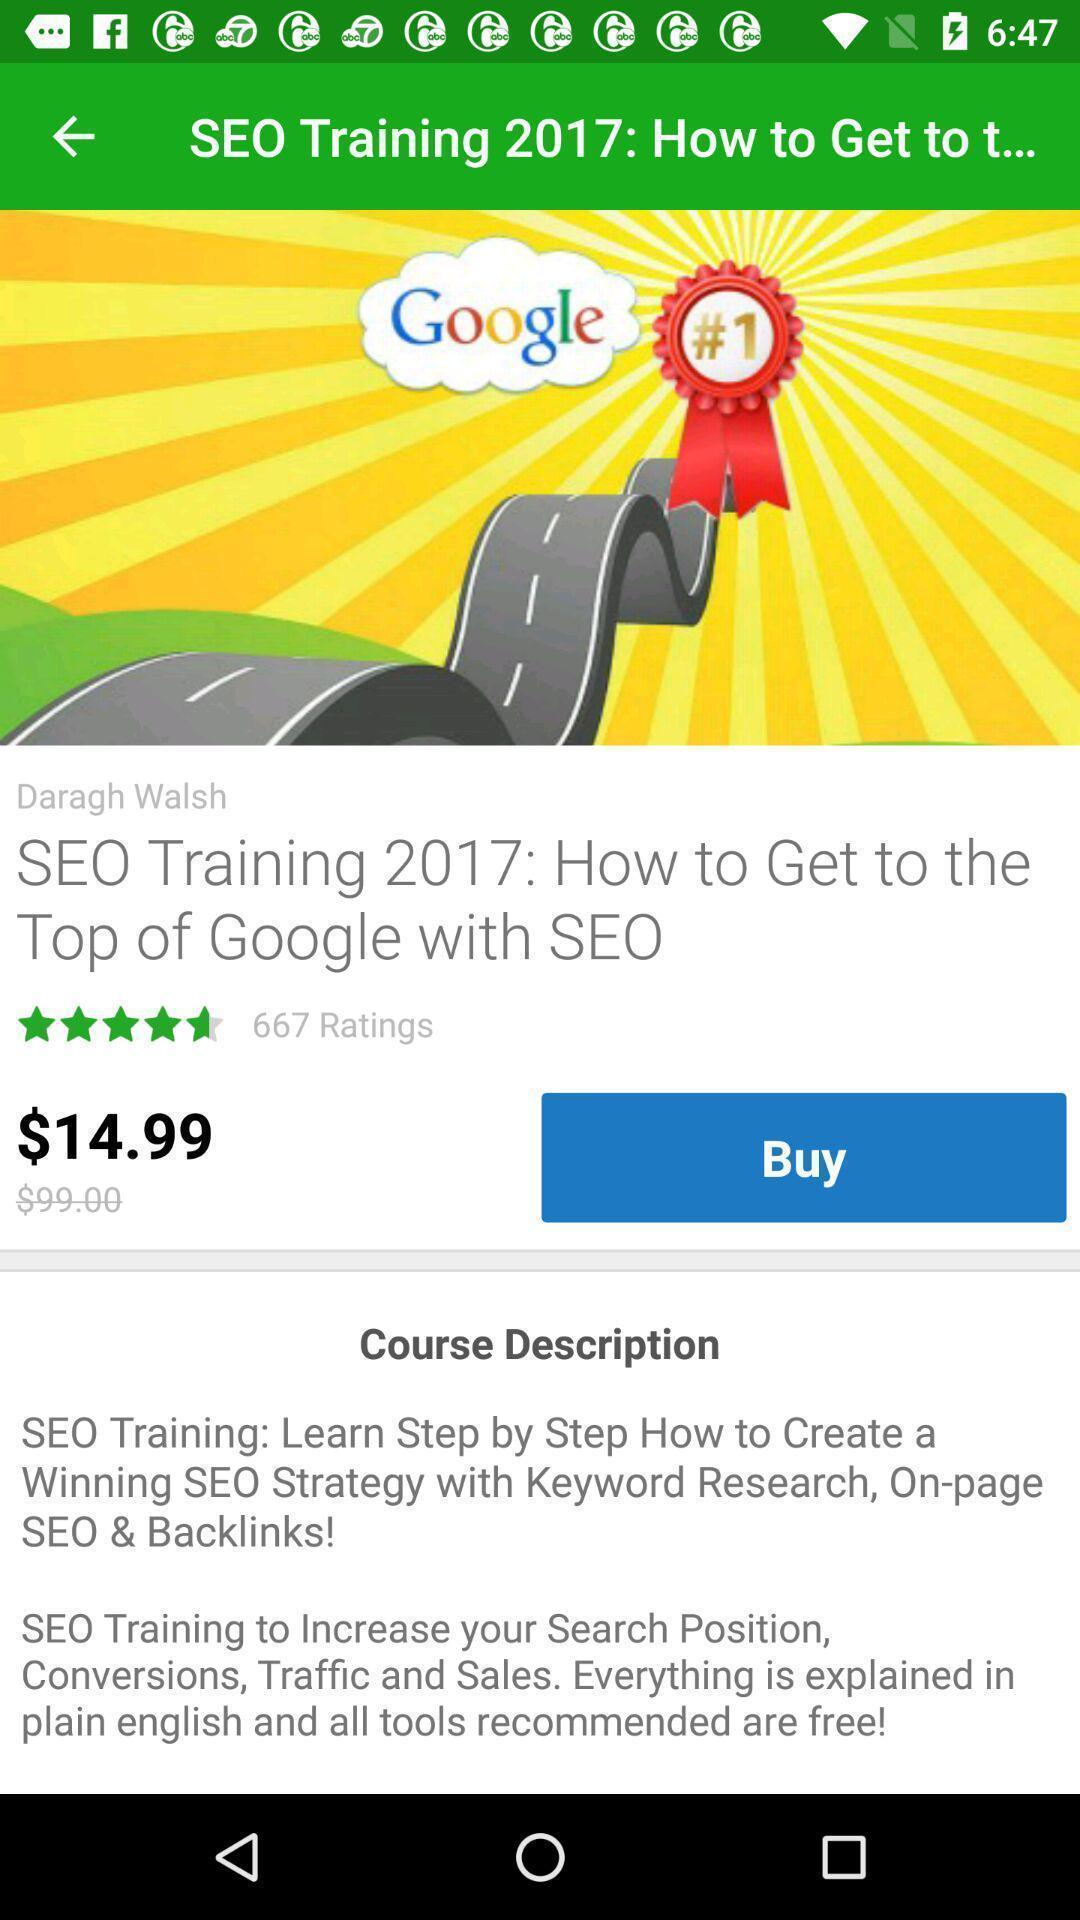Give me a summary of this screen capture. Screen displaying the page of training app. 